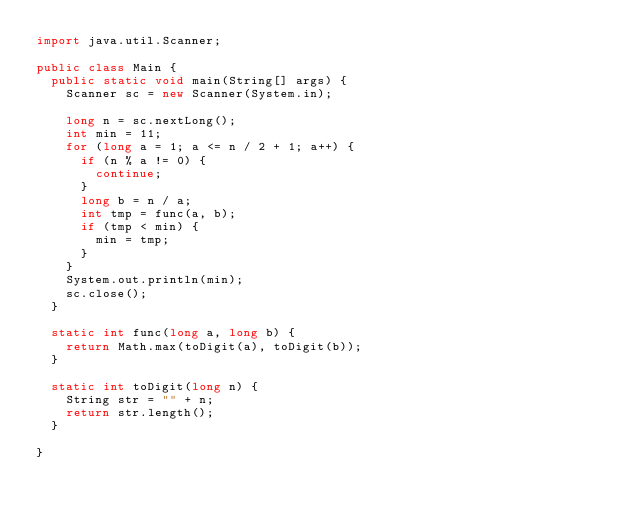<code> <loc_0><loc_0><loc_500><loc_500><_Java_>import java.util.Scanner;

public class Main {
	public static void main(String[] args) {
		Scanner sc = new Scanner(System.in);

		long n = sc.nextLong();
		int min = 11;
		for (long a = 1; a <= n / 2 + 1; a++) {
			if (n % a != 0) {
				continue;
			}
			long b = n / a;
			int tmp = func(a, b);
			if (tmp < min) {
				min = tmp;
			}
		}
		System.out.println(min);
		sc.close();
	}

	static int func(long a, long b) {
		return Math.max(toDigit(a), toDigit(b));
	}

	static int toDigit(long n) {
		String str = "" + n;
		return str.length();
	}

}
</code> 